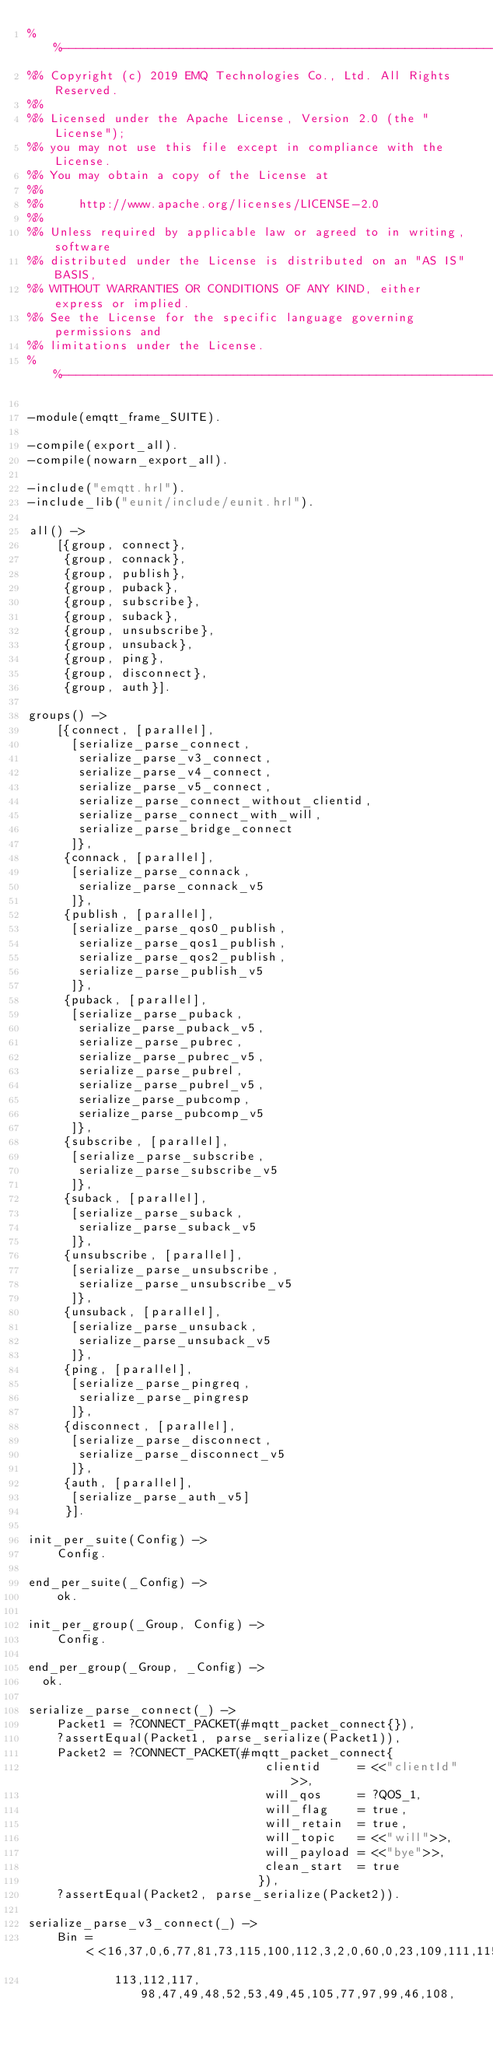Convert code to text. <code><loc_0><loc_0><loc_500><loc_500><_Erlang_>%%--------------------------------------------------------------------
%% Copyright (c) 2019 EMQ Technologies Co., Ltd. All Rights Reserved.
%%
%% Licensed under the Apache License, Version 2.0 (the "License");
%% you may not use this file except in compliance with the License.
%% You may obtain a copy of the License at
%%
%%     http://www.apache.org/licenses/LICENSE-2.0
%%
%% Unless required by applicable law or agreed to in writing, software
%% distributed under the License is distributed on an "AS IS" BASIS,
%% WITHOUT WARRANTIES OR CONDITIONS OF ANY KIND, either express or implied.
%% See the License for the specific language governing permissions and
%% limitations under the License.
%%--------------------------------------------------------------------

-module(emqtt_frame_SUITE).

-compile(export_all).
-compile(nowarn_export_all).

-include("emqtt.hrl").
-include_lib("eunit/include/eunit.hrl").

all() ->
    [{group, connect},
     {group, connack},
     {group, publish},
     {group, puback},
     {group, subscribe},
     {group, suback},
     {group, unsubscribe},
     {group, unsuback},
     {group, ping},
     {group, disconnect},
     {group, auth}].

groups() ->
    [{connect, [parallel],
      [serialize_parse_connect,
       serialize_parse_v3_connect,
       serialize_parse_v4_connect,
       serialize_parse_v5_connect,
       serialize_parse_connect_without_clientid,
       serialize_parse_connect_with_will,
       serialize_parse_bridge_connect
      ]},
     {connack, [parallel],
      [serialize_parse_connack,
       serialize_parse_connack_v5
      ]},
     {publish, [parallel],
      [serialize_parse_qos0_publish,
       serialize_parse_qos1_publish,
       serialize_parse_qos2_publish,
       serialize_parse_publish_v5
      ]},
     {puback, [parallel],
      [serialize_parse_puback,
       serialize_parse_puback_v5,
       serialize_parse_pubrec,
       serialize_parse_pubrec_v5,
       serialize_parse_pubrel,
       serialize_parse_pubrel_v5,
       serialize_parse_pubcomp,
       serialize_parse_pubcomp_v5
      ]},
     {subscribe, [parallel],
      [serialize_parse_subscribe,
       serialize_parse_subscribe_v5
      ]},
     {suback, [parallel],
      [serialize_parse_suback,
       serialize_parse_suback_v5
      ]},
     {unsubscribe, [parallel],
      [serialize_parse_unsubscribe,
       serialize_parse_unsubscribe_v5
      ]},
     {unsuback, [parallel],
      [serialize_parse_unsuback,
       serialize_parse_unsuback_v5
      ]},
     {ping, [parallel],
      [serialize_parse_pingreq,
       serialize_parse_pingresp
      ]},
     {disconnect, [parallel],
      [serialize_parse_disconnect,
       serialize_parse_disconnect_v5
      ]},
     {auth, [parallel],
      [serialize_parse_auth_v5]
     }].

init_per_suite(Config) ->
    Config.

end_per_suite(_Config) ->
    ok.

init_per_group(_Group, Config) ->
    Config.

end_per_group(_Group, _Config) ->
	ok.

serialize_parse_connect(_) ->
    Packet1 = ?CONNECT_PACKET(#mqtt_packet_connect{}),
    ?assertEqual(Packet1, parse_serialize(Packet1)),
    Packet2 = ?CONNECT_PACKET(#mqtt_packet_connect{
                                 clientid     = <<"clientId">>,
                                 will_qos     = ?QOS_1,
                                 will_flag    = true,
                                 will_retain  = true,
                                 will_topic   = <<"will">>,
                                 will_payload = <<"bye">>,
                                 clean_start  = true
                                }),
    ?assertEqual(Packet2, parse_serialize(Packet2)).

serialize_parse_v3_connect(_) ->
    Bin = <<16,37,0,6,77,81,73,115,100,112,3,2,0,60,0,23,109,111,115,
            113,112,117, 98,47,49,48,52,53,49,45,105,77,97,99,46,108,</code> 